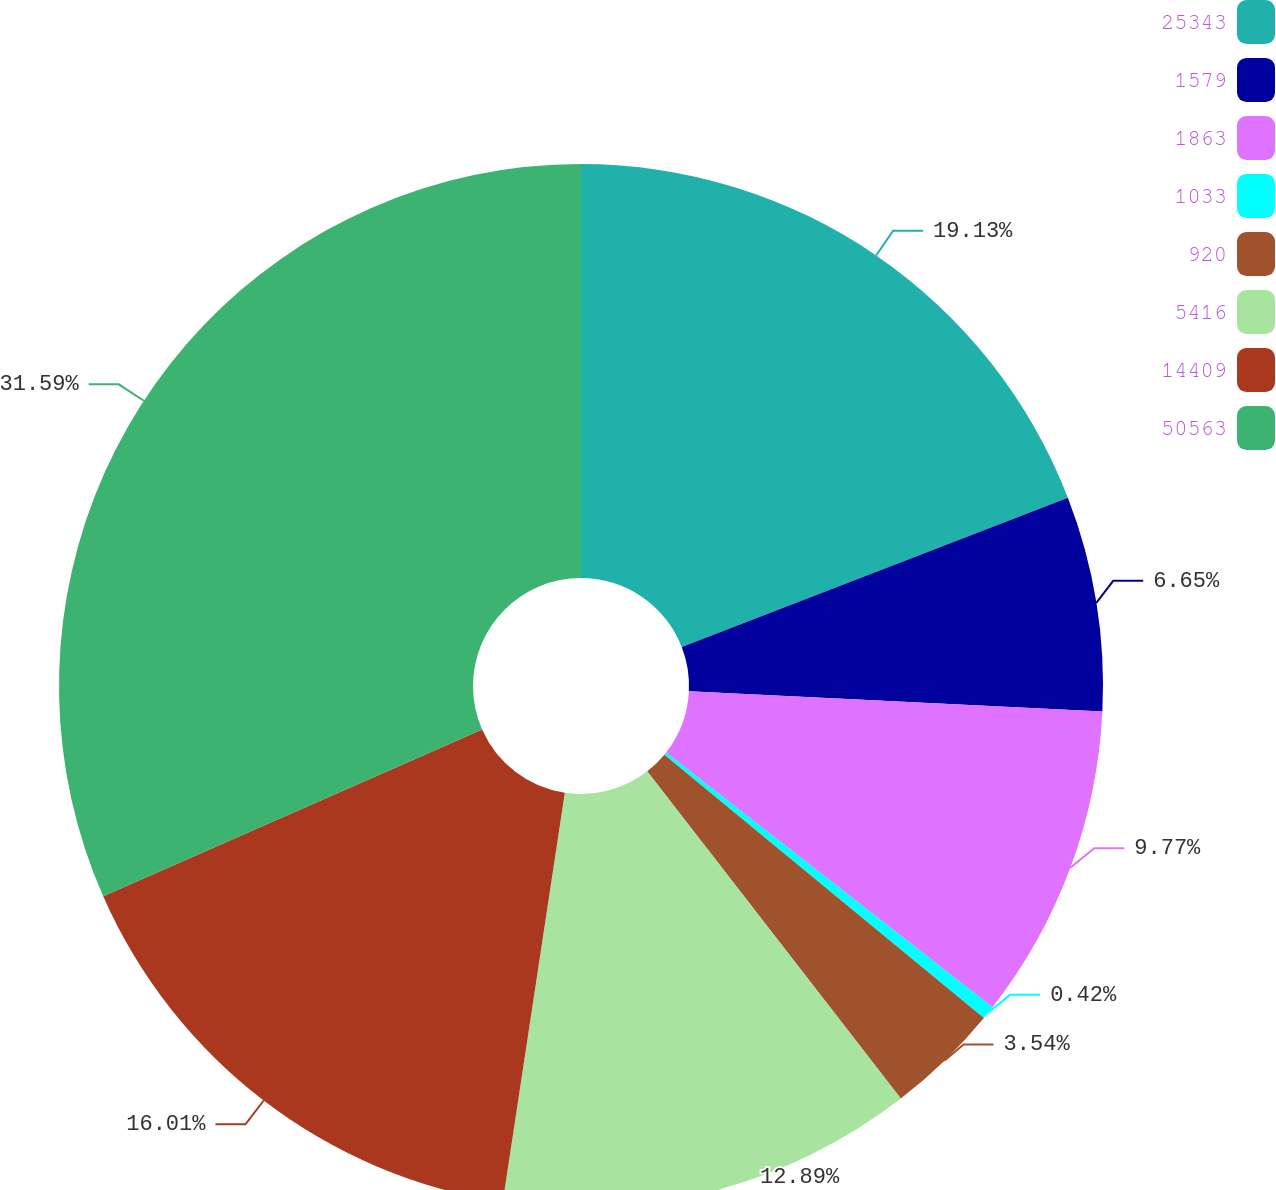Convert chart to OTSL. <chart><loc_0><loc_0><loc_500><loc_500><pie_chart><fcel>25343<fcel>1579<fcel>1863<fcel>1033<fcel>920<fcel>5416<fcel>14409<fcel>50563<nl><fcel>19.13%<fcel>6.65%<fcel>9.77%<fcel>0.42%<fcel>3.54%<fcel>12.89%<fcel>16.01%<fcel>31.6%<nl></chart> 